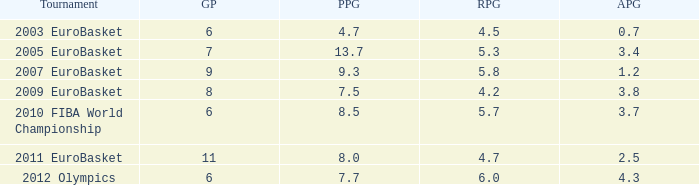How many games played have 4.7 as points per game? 6.0. 